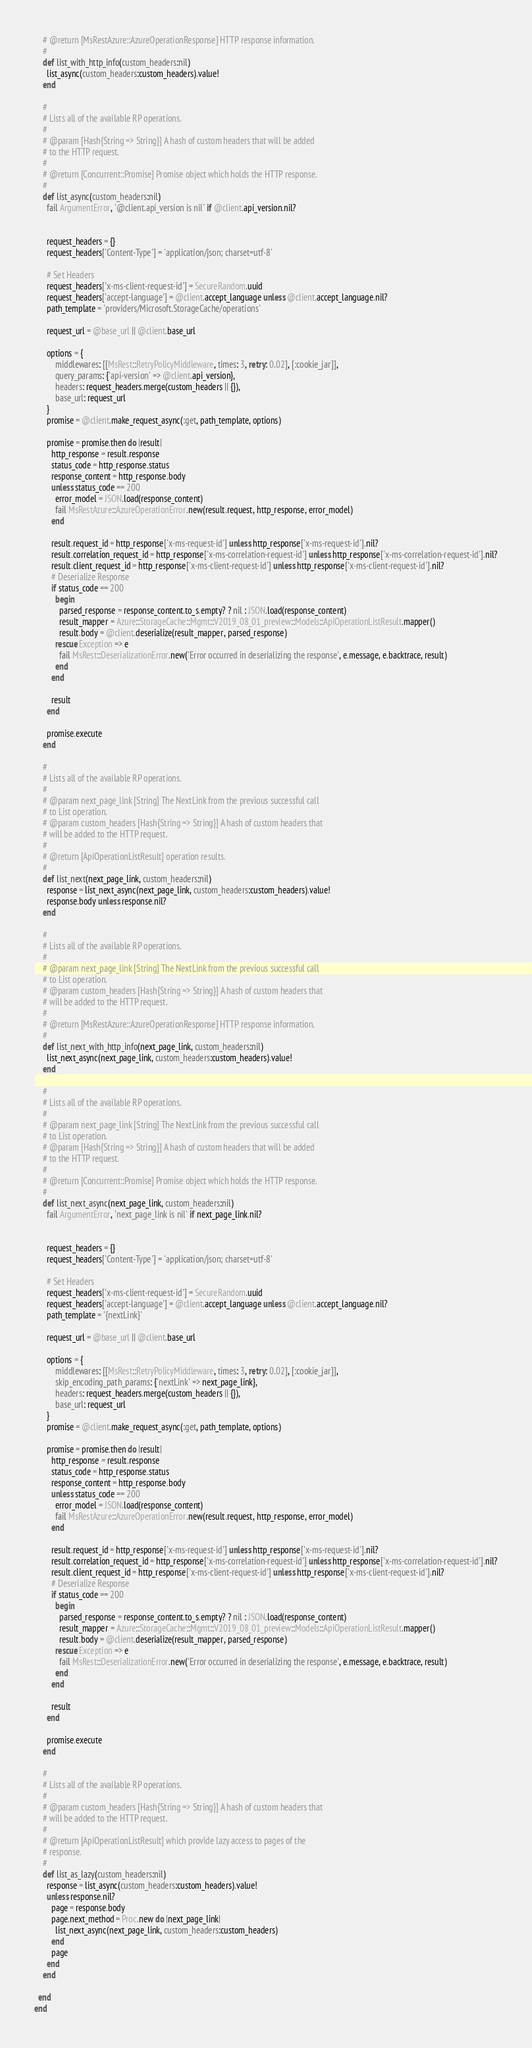<code> <loc_0><loc_0><loc_500><loc_500><_Ruby_>    # @return [MsRestAzure::AzureOperationResponse] HTTP response information.
    #
    def list_with_http_info(custom_headers:nil)
      list_async(custom_headers:custom_headers).value!
    end

    #
    # Lists all of the available RP operations.
    #
    # @param [Hash{String => String}] A hash of custom headers that will be added
    # to the HTTP request.
    #
    # @return [Concurrent::Promise] Promise object which holds the HTTP response.
    #
    def list_async(custom_headers:nil)
      fail ArgumentError, '@client.api_version is nil' if @client.api_version.nil?


      request_headers = {}
      request_headers['Content-Type'] = 'application/json; charset=utf-8'

      # Set Headers
      request_headers['x-ms-client-request-id'] = SecureRandom.uuid
      request_headers['accept-language'] = @client.accept_language unless @client.accept_language.nil?
      path_template = 'providers/Microsoft.StorageCache/operations'

      request_url = @base_url || @client.base_url

      options = {
          middlewares: [[MsRest::RetryPolicyMiddleware, times: 3, retry: 0.02], [:cookie_jar]],
          query_params: {'api-version' => @client.api_version},
          headers: request_headers.merge(custom_headers || {}),
          base_url: request_url
      }
      promise = @client.make_request_async(:get, path_template, options)

      promise = promise.then do |result|
        http_response = result.response
        status_code = http_response.status
        response_content = http_response.body
        unless status_code == 200
          error_model = JSON.load(response_content)
          fail MsRestAzure::AzureOperationError.new(result.request, http_response, error_model)
        end

        result.request_id = http_response['x-ms-request-id'] unless http_response['x-ms-request-id'].nil?
        result.correlation_request_id = http_response['x-ms-correlation-request-id'] unless http_response['x-ms-correlation-request-id'].nil?
        result.client_request_id = http_response['x-ms-client-request-id'] unless http_response['x-ms-client-request-id'].nil?
        # Deserialize Response
        if status_code == 200
          begin
            parsed_response = response_content.to_s.empty? ? nil : JSON.load(response_content)
            result_mapper = Azure::StorageCache::Mgmt::V2019_08_01_preview::Models::ApiOperationListResult.mapper()
            result.body = @client.deserialize(result_mapper, parsed_response)
          rescue Exception => e
            fail MsRest::DeserializationError.new('Error occurred in deserializing the response', e.message, e.backtrace, result)
          end
        end

        result
      end

      promise.execute
    end

    #
    # Lists all of the available RP operations.
    #
    # @param next_page_link [String] The NextLink from the previous successful call
    # to List operation.
    # @param custom_headers [Hash{String => String}] A hash of custom headers that
    # will be added to the HTTP request.
    #
    # @return [ApiOperationListResult] operation results.
    #
    def list_next(next_page_link, custom_headers:nil)
      response = list_next_async(next_page_link, custom_headers:custom_headers).value!
      response.body unless response.nil?
    end

    #
    # Lists all of the available RP operations.
    #
    # @param next_page_link [String] The NextLink from the previous successful call
    # to List operation.
    # @param custom_headers [Hash{String => String}] A hash of custom headers that
    # will be added to the HTTP request.
    #
    # @return [MsRestAzure::AzureOperationResponse] HTTP response information.
    #
    def list_next_with_http_info(next_page_link, custom_headers:nil)
      list_next_async(next_page_link, custom_headers:custom_headers).value!
    end

    #
    # Lists all of the available RP operations.
    #
    # @param next_page_link [String] The NextLink from the previous successful call
    # to List operation.
    # @param [Hash{String => String}] A hash of custom headers that will be added
    # to the HTTP request.
    #
    # @return [Concurrent::Promise] Promise object which holds the HTTP response.
    #
    def list_next_async(next_page_link, custom_headers:nil)
      fail ArgumentError, 'next_page_link is nil' if next_page_link.nil?


      request_headers = {}
      request_headers['Content-Type'] = 'application/json; charset=utf-8'

      # Set Headers
      request_headers['x-ms-client-request-id'] = SecureRandom.uuid
      request_headers['accept-language'] = @client.accept_language unless @client.accept_language.nil?
      path_template = '{nextLink}'

      request_url = @base_url || @client.base_url

      options = {
          middlewares: [[MsRest::RetryPolicyMiddleware, times: 3, retry: 0.02], [:cookie_jar]],
          skip_encoding_path_params: {'nextLink' => next_page_link},
          headers: request_headers.merge(custom_headers || {}),
          base_url: request_url
      }
      promise = @client.make_request_async(:get, path_template, options)

      promise = promise.then do |result|
        http_response = result.response
        status_code = http_response.status
        response_content = http_response.body
        unless status_code == 200
          error_model = JSON.load(response_content)
          fail MsRestAzure::AzureOperationError.new(result.request, http_response, error_model)
        end

        result.request_id = http_response['x-ms-request-id'] unless http_response['x-ms-request-id'].nil?
        result.correlation_request_id = http_response['x-ms-correlation-request-id'] unless http_response['x-ms-correlation-request-id'].nil?
        result.client_request_id = http_response['x-ms-client-request-id'] unless http_response['x-ms-client-request-id'].nil?
        # Deserialize Response
        if status_code == 200
          begin
            parsed_response = response_content.to_s.empty? ? nil : JSON.load(response_content)
            result_mapper = Azure::StorageCache::Mgmt::V2019_08_01_preview::Models::ApiOperationListResult.mapper()
            result.body = @client.deserialize(result_mapper, parsed_response)
          rescue Exception => e
            fail MsRest::DeserializationError.new('Error occurred in deserializing the response', e.message, e.backtrace, result)
          end
        end

        result
      end

      promise.execute
    end

    #
    # Lists all of the available RP operations.
    #
    # @param custom_headers [Hash{String => String}] A hash of custom headers that
    # will be added to the HTTP request.
    #
    # @return [ApiOperationListResult] which provide lazy access to pages of the
    # response.
    #
    def list_as_lazy(custom_headers:nil)
      response = list_async(custom_headers:custom_headers).value!
      unless response.nil?
        page = response.body
        page.next_method = Proc.new do |next_page_link|
          list_next_async(next_page_link, custom_headers:custom_headers)
        end
        page
      end
    end

  end
end
</code> 